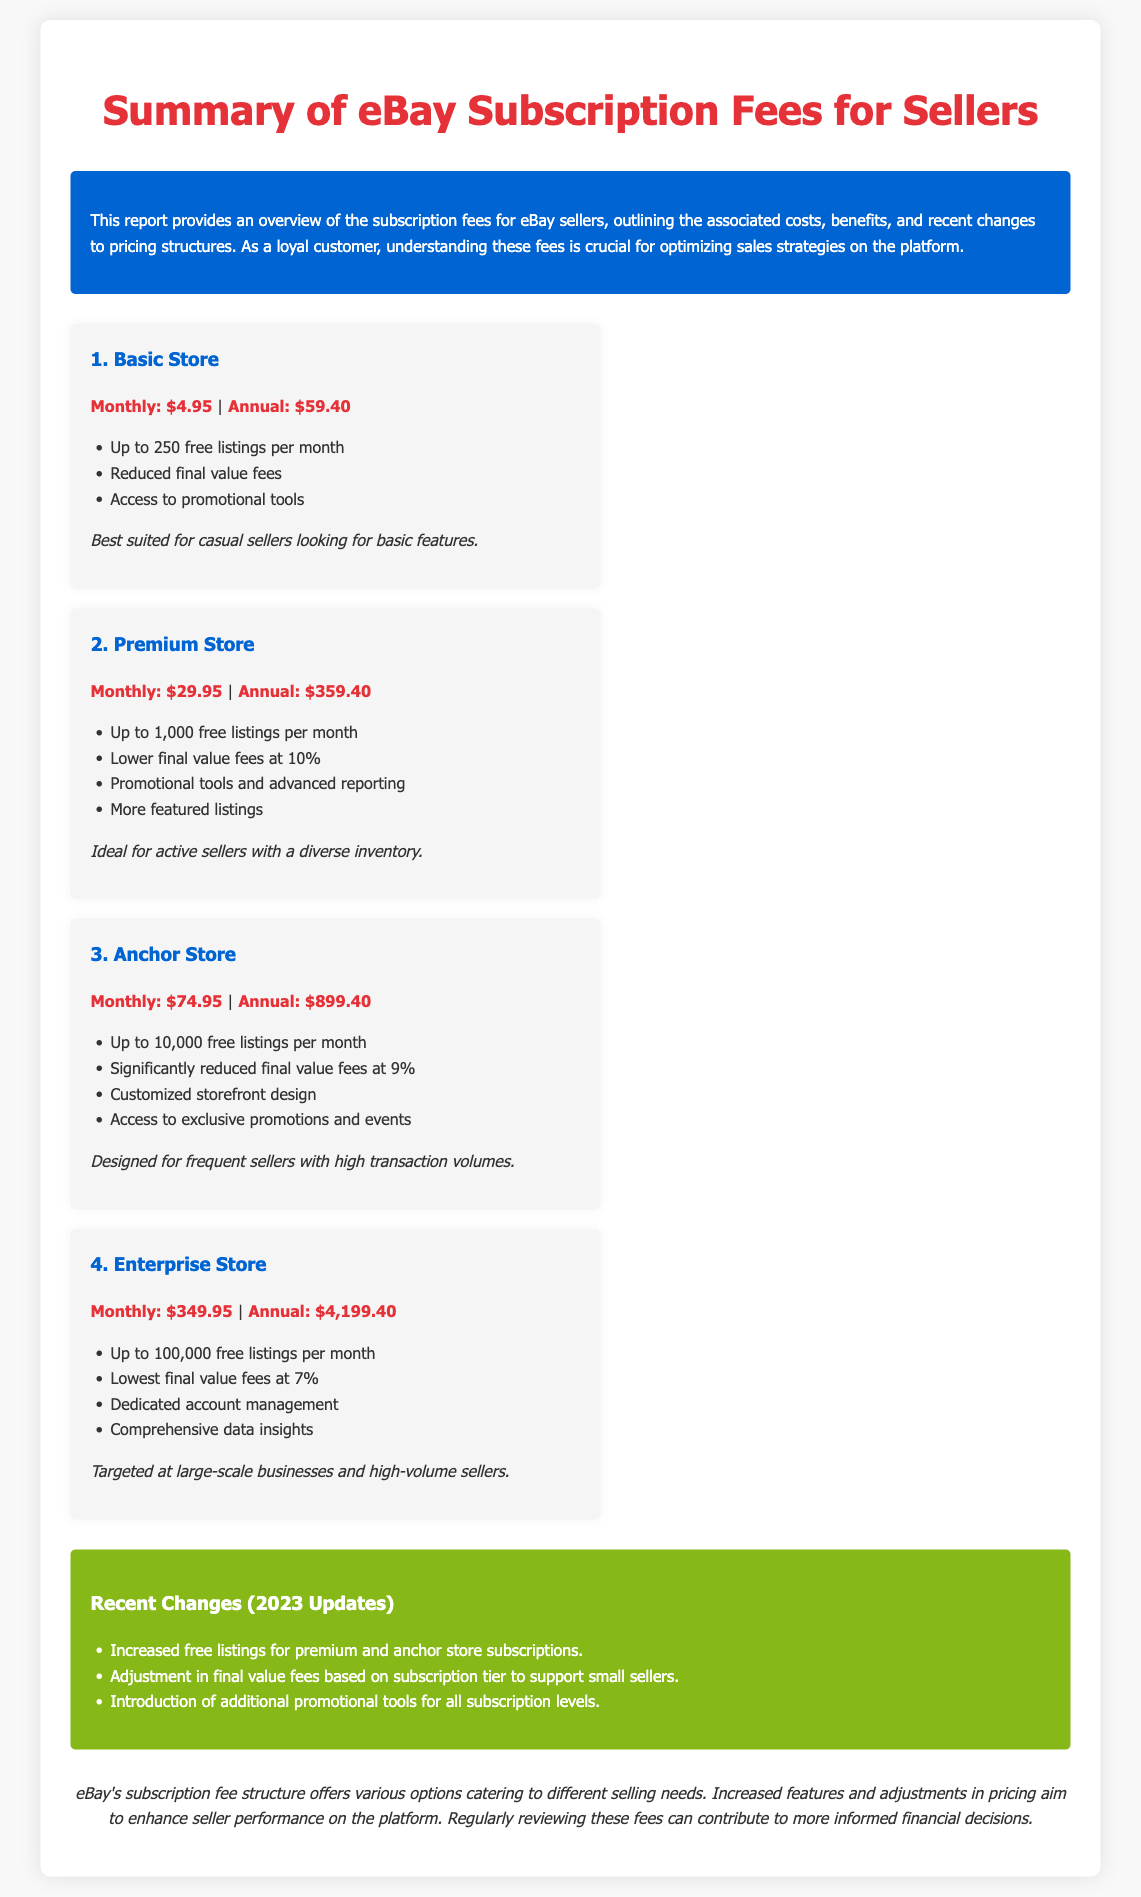What is the monthly fee for the Basic Store? The document states that the monthly fee for the Basic Store is $4.95.
Answer: $4.95 How many free listings are included in the Anchor Store? The document indicates that the Anchor Store includes up to 10,000 free listings per month.
Answer: 10,000 What is the annual fee for the Enterprise Store? According to the document, the annual fee for the Enterprise Store is $4,199.40.
Answer: $4,199.40 Which subscription tier has the lowest final value fees? The document specifies that the Enterprise Store has the lowest final value fees at 7%.
Answer: 7% What recent change affected free listings? The document mentions that free listings were increased for premium and anchor store subscriptions.
Answer: Increased free listings How does the final value fee change for premium sellers in 2023? The document states that the adjustment in final value fees was made based on subscription tier to support small sellers.
Answer: Adjusted based on tier What is the primary benefit of the Basic Store? The document states that the Basic Store is best suited for casual sellers looking for basic features.
Answer: Basic features What is a notable feature of the Enterprise Store? The document highlights that the Enterprise Store includes dedicated account management as a notable feature.
Answer: Dedicated account management How many tiers of subscription does eBay offer for sellers? The document outlines four tiers of subscription for sellers.
Answer: Four tiers 